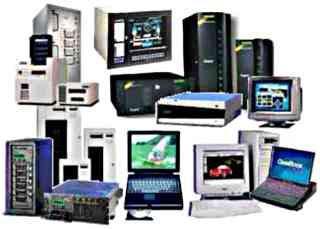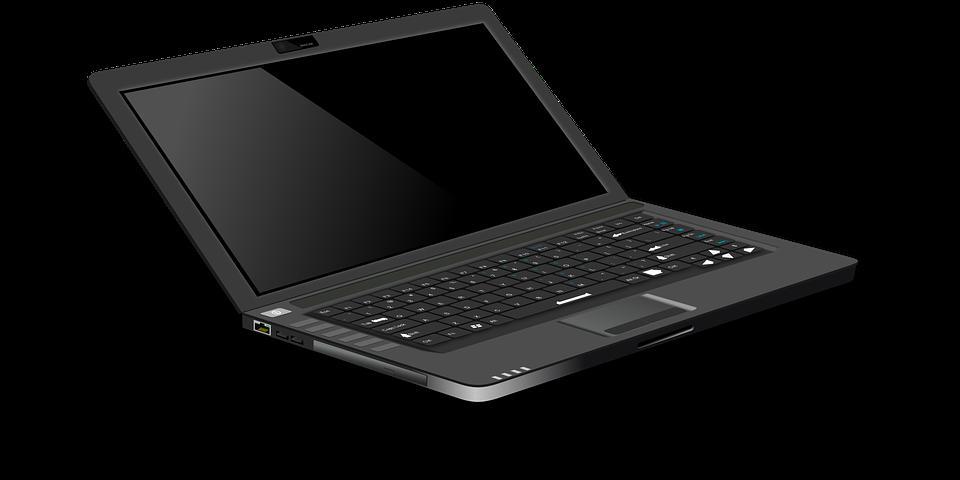The first image is the image on the left, the second image is the image on the right. Given the left and right images, does the statement "The laptop in the image on the left is facing right." hold true? Answer yes or no. No. 